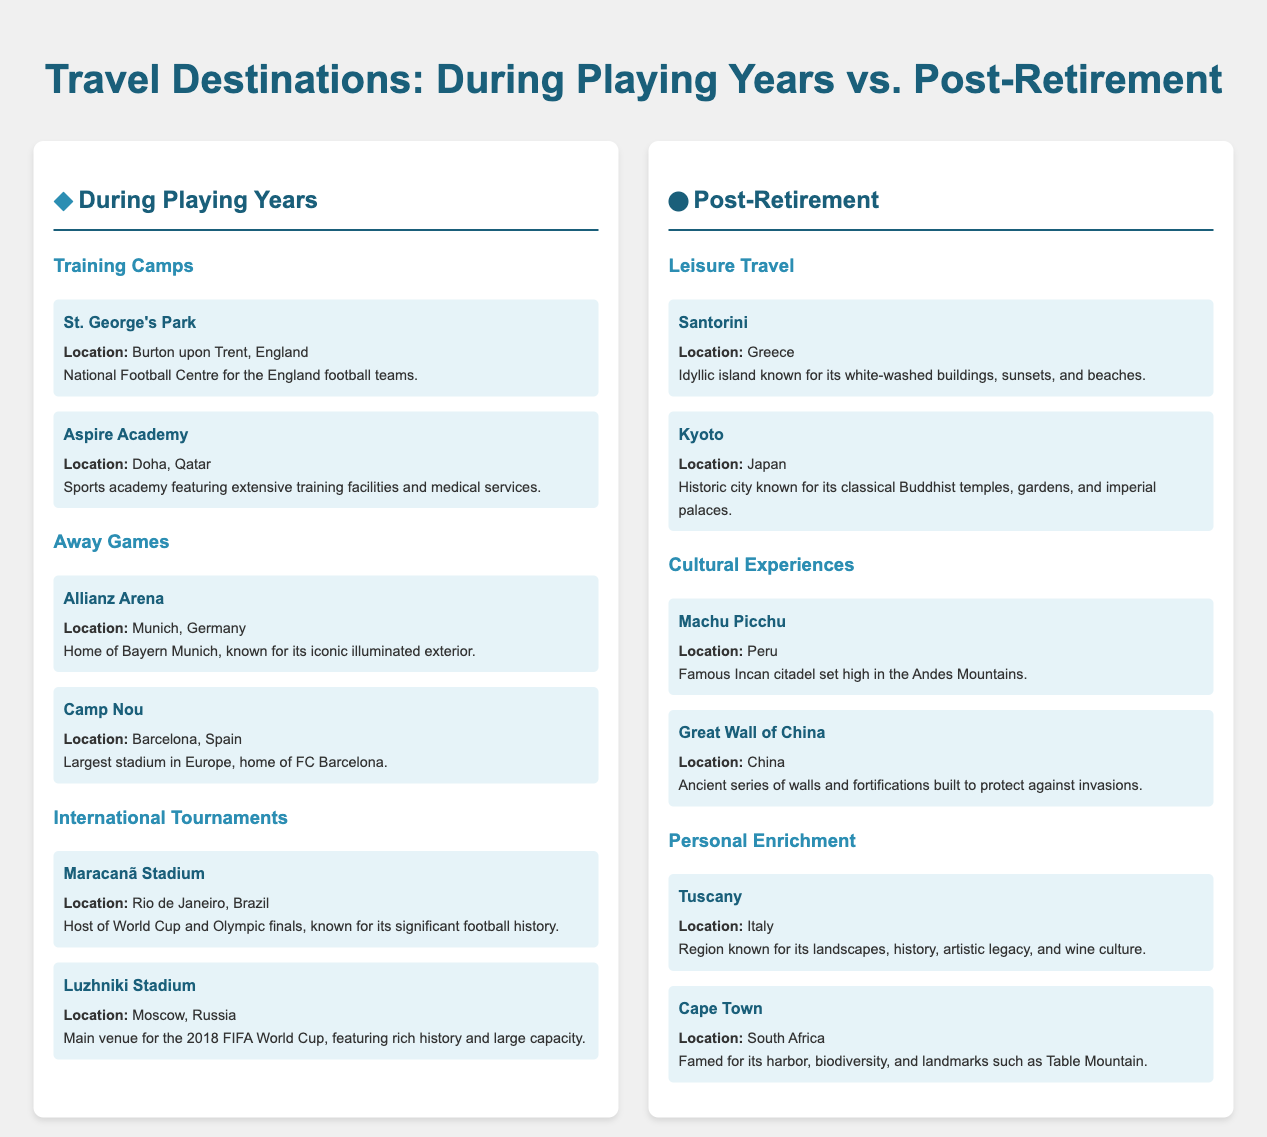What is the location of St. George's Park? St. George's Park is located in Burton upon Trent, England, as stated in the document.
Answer: Burton upon Trent, England What type of experiences are available in Post-Retirement travel? Post-Retirement travel includes Leisure Travel, Cultural Experiences, and Personal Enrichment, which are detailed in the infographic.
Answer: Leisure Travel, Cultural Experiences, Personal Enrichment What is the iconic feature of Camp Nou? Camp Nou is known as the largest stadium in Europe, which is highlighted in its description.
Answer: Largest stadium in Europe Which destination is associated with sports training facilities in Qatar? Aspire Academy is highlighted in the document as a sports academy in Doha, Qatar, providing training facilities.
Answer: Aspire Academy How many destinations are listed under International Tournaments? The document lists two destinations under the International Tournaments category.
Answer: Two Which country's landmark is the Great Wall associated with? The Great Wall of China, noted in the document, is associated with China as indicated.
Answer: China What is a notable city highlighted for its classical Buddhist temples? Kyoto is recognized for its classical Buddhist temples, leading this category in Post-Retirement travel.
Answer: Kyoto Which famous Incan site is included in the cultural experiences? Machu Picchu is named in the cultural experiences section of the document.
Answer: Machu Picchu What is the primary focus of travel during playing years? The travel during playing years focuses on Training Camps, Away Games, and International Tournaments as detailed in the infographic.
Answer: Training Camps, Away Games, International Tournaments 